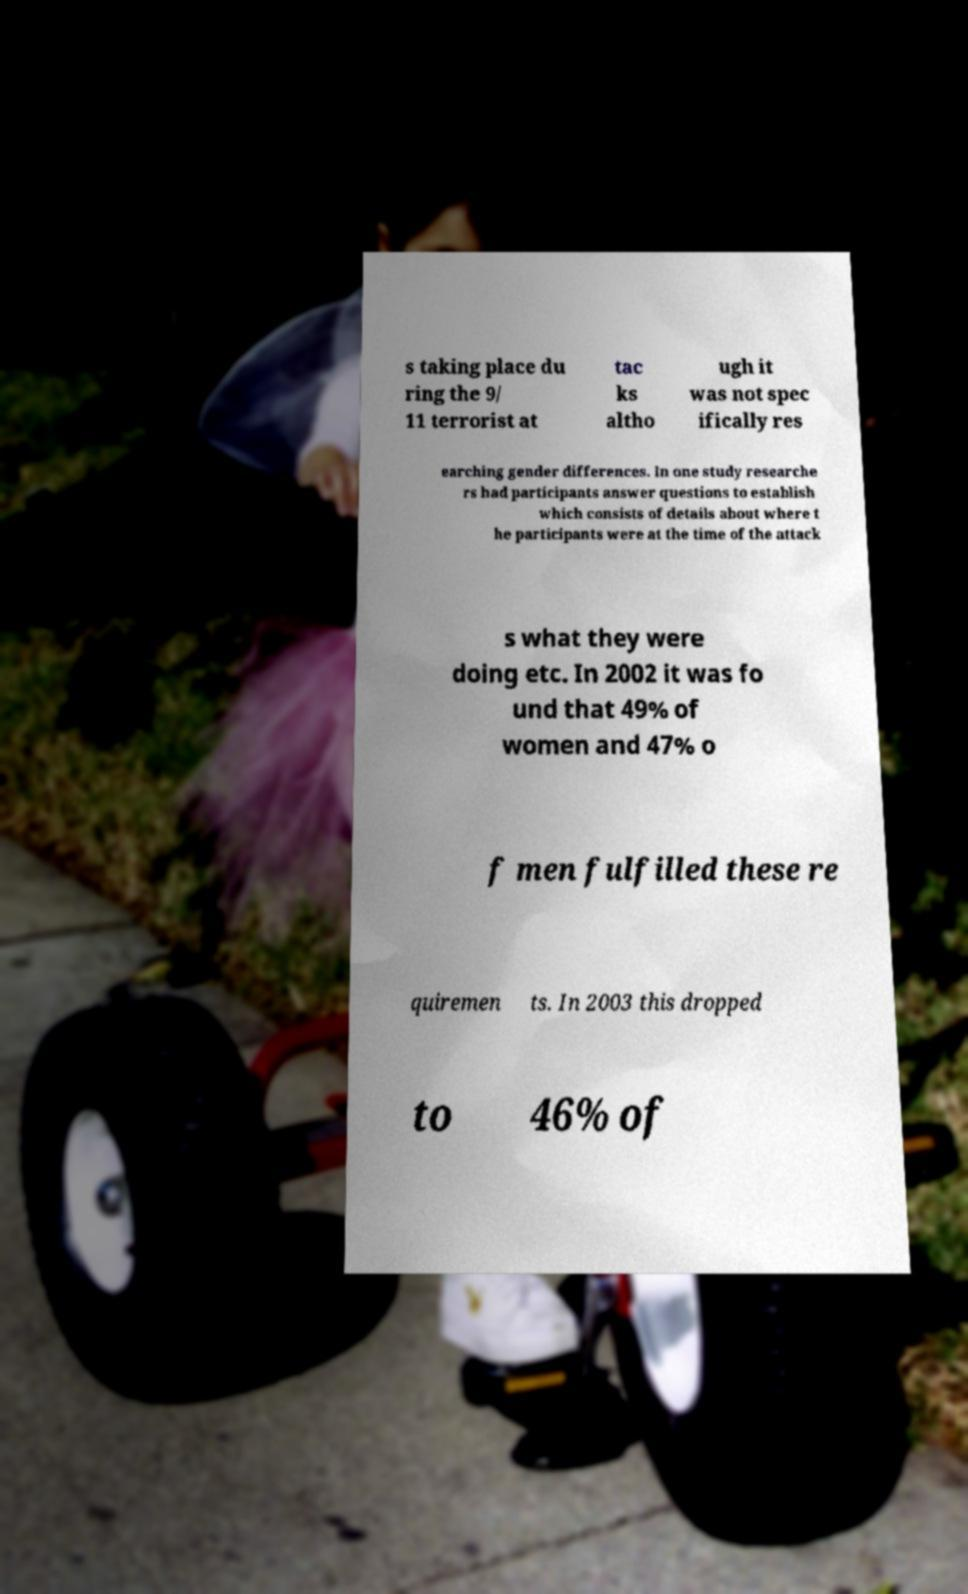I need the written content from this picture converted into text. Can you do that? s taking place du ring the 9/ 11 terrorist at tac ks altho ugh it was not spec ifically res earching gender differences. In one study researche rs had participants answer questions to establish which consists of details about where t he participants were at the time of the attack s what they were doing etc. In 2002 it was fo und that 49% of women and 47% o f men fulfilled these re quiremen ts. In 2003 this dropped to 46% of 